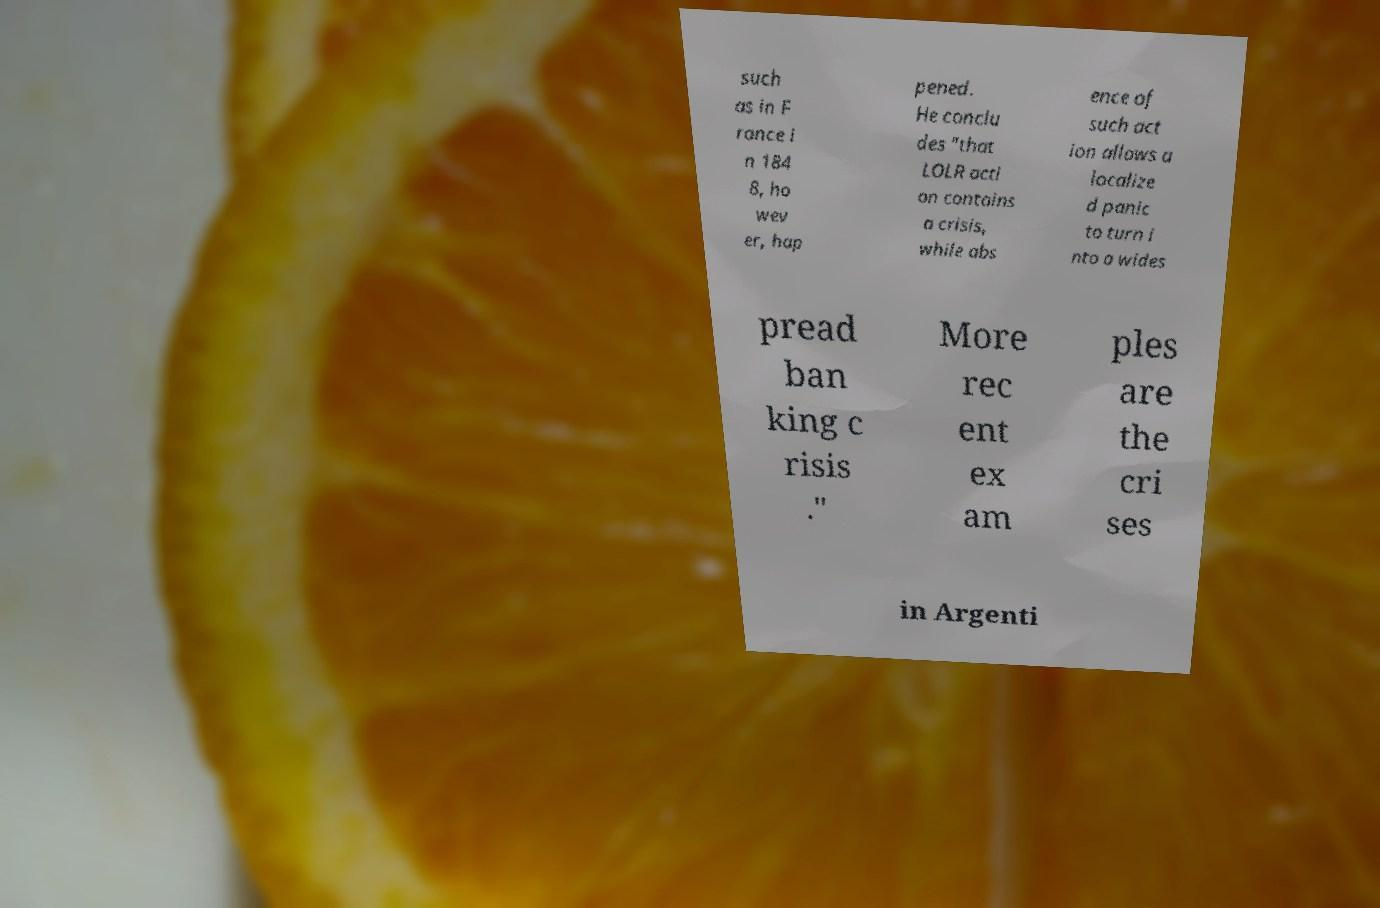Could you extract and type out the text from this image? such as in F rance i n 184 8, ho wev er, hap pened. He conclu des "that LOLR acti on contains a crisis, while abs ence of such act ion allows a localize d panic to turn i nto a wides pread ban king c risis ." More rec ent ex am ples are the cri ses in Argenti 